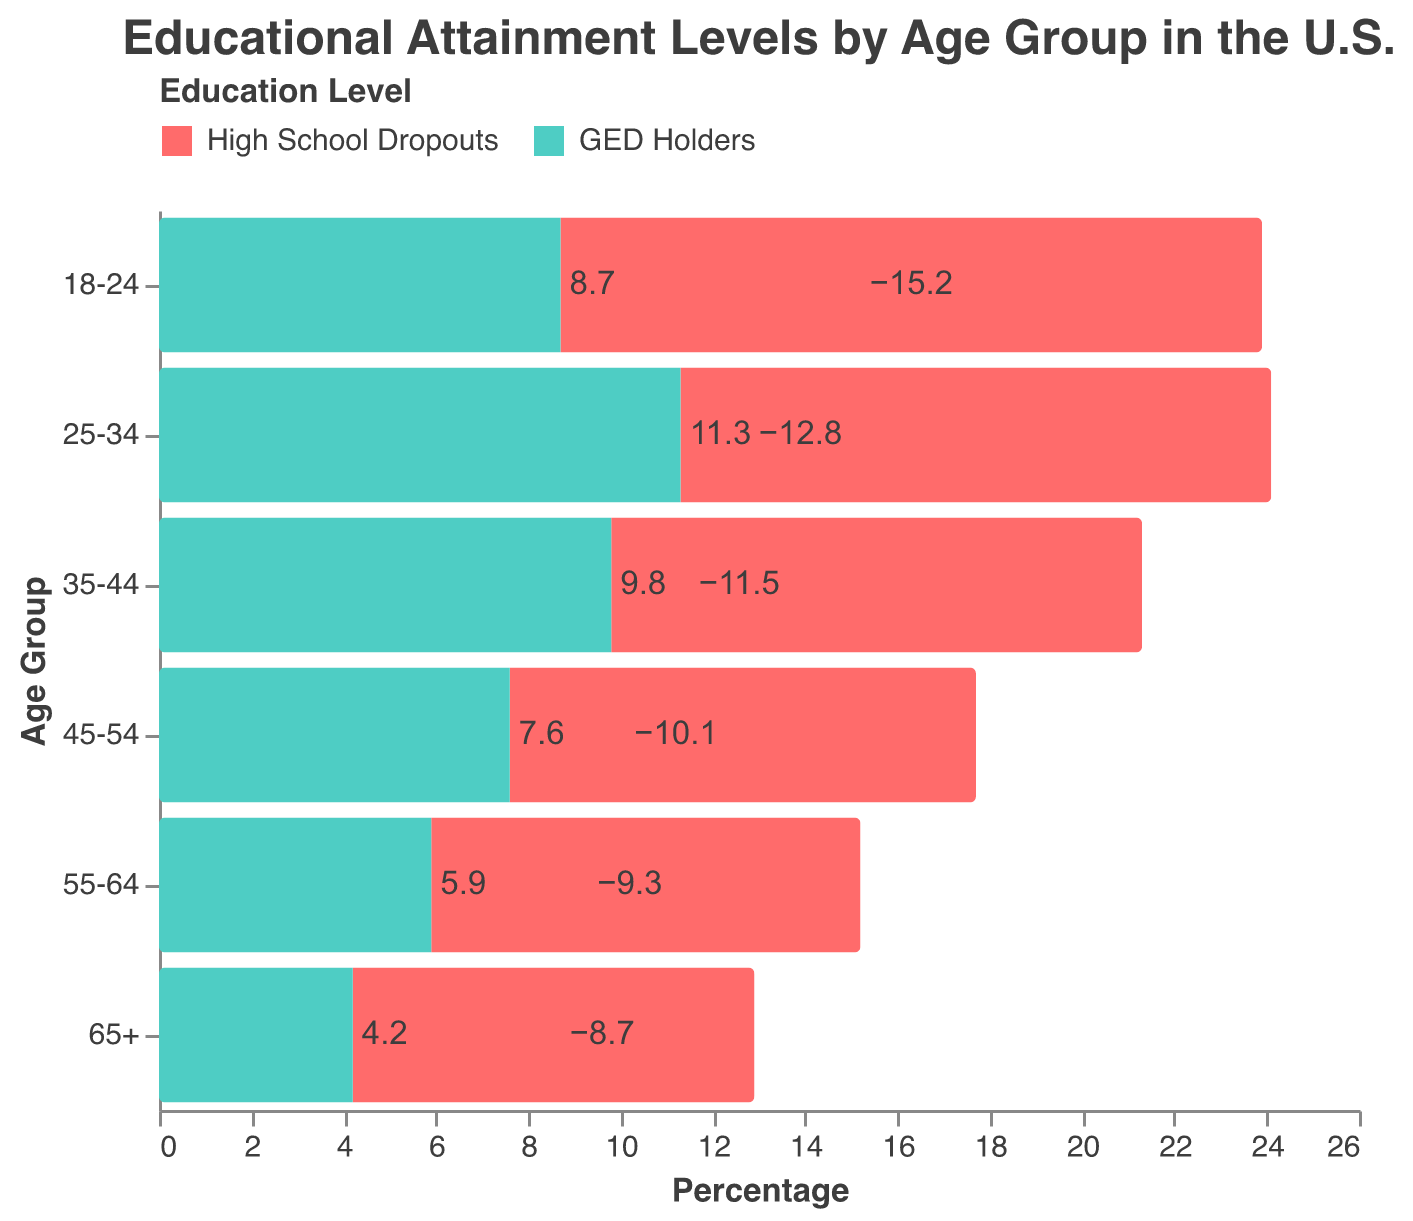What are the two categories represented in the figure? The figure has a color legend that shows "High School Dropouts" in red and "GED Holders" in green. These are the two educational attainment categories being compared.
Answer: High School Dropouts and GED Holders Which age group has the highest percentage of high school dropouts? Looking at the negative side of the x-axis, the bar with the greatest magnitude represents the 18-24 age group with -15.2%.
Answer: 18-24 How does the percentage of GED holders change across age groups? From 18-24 (8.7%) to 65+ (4.2%), the percentage of GED holders decreases gradually in each age group.
Answer: Decreases Which age group has the smallest percentage of GED holders? By examining the positive side of the x-axis, the bar with the smallest length represents the 65+ age group with 4.2%.
Answer: 65+ What is the difference in the percentages of GED holders between the age groups 25-34 and 45-54? For the age group 25-34, the percentage of GED holders is 11.3%. For the age group 45-54, it is 7.6%. The difference is 11.3% - 7.6% = 3.7%.
Answer: 3.7% Which age group shows the greatest gap between high school dropouts and GED holders? By comparing the vertical distance between the negative and positive bars in the figure, the 25-34 age group has the greatest gap: 12.8% (dropouts) + 11.3% (GED holders) = 24.1%.
Answer: 25-34 How does the percentage of high school dropouts in the 55-64 age group compare to the 65+ age group? The percentage for the 55-64 age group is -9.3% and for the 65+ age group is -8.7%, indicating that the 55-64 age group has a slightly higher dropout rate by 0.6%.
Answer: 55-64 has a higher dropout rate What is the average percentage of high school dropouts across all age groups? Summing the percentages: -15.2 + -12.8 + -11.5 + -10.1 + -9.3 + -8.7 = -67.6. There are 6 age groups, so the average is -67.6 / 6 = -11.27%.
Answer: -11.27% What trend can be observed in high school dropout rates as age increases? The dropout rates decrease as age increases, starting from -15.2% in the 18-24 age group to -8.7% in the 65+ age group.
Answer: Decreases 